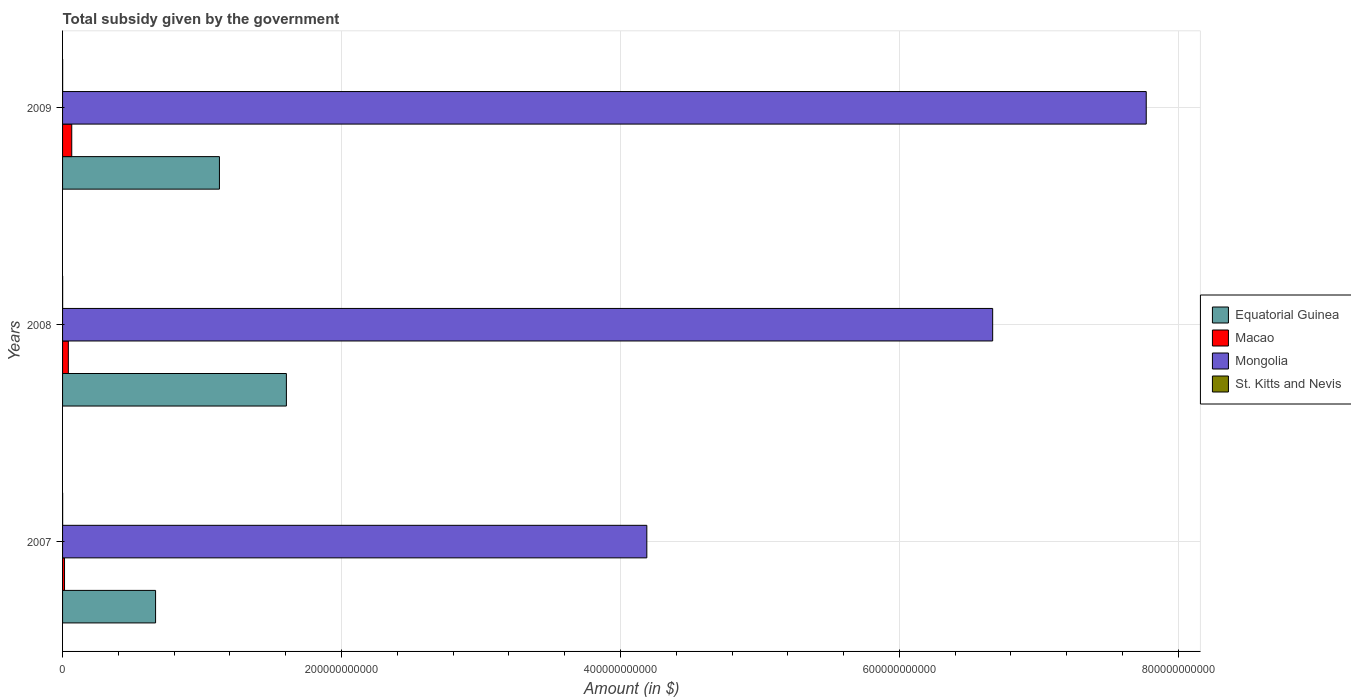How many groups of bars are there?
Offer a very short reply. 3. Are the number of bars per tick equal to the number of legend labels?
Keep it short and to the point. Yes. How many bars are there on the 1st tick from the top?
Ensure brevity in your answer.  4. In how many cases, is the number of bars for a given year not equal to the number of legend labels?
Provide a succinct answer. 0. What is the total revenue collected by the government in Mongolia in 2007?
Keep it short and to the point. 4.19e+11. Across all years, what is the maximum total revenue collected by the government in Equatorial Guinea?
Provide a succinct answer. 1.60e+11. Across all years, what is the minimum total revenue collected by the government in Equatorial Guinea?
Make the answer very short. 6.67e+1. In which year was the total revenue collected by the government in St. Kitts and Nevis maximum?
Your answer should be very brief. 2009. What is the total total revenue collected by the government in Mongolia in the graph?
Ensure brevity in your answer.  1.86e+12. What is the difference between the total revenue collected by the government in Mongolia in 2007 and that in 2008?
Provide a succinct answer. -2.48e+11. What is the difference between the total revenue collected by the government in Macao in 2009 and the total revenue collected by the government in Mongolia in 2008?
Provide a short and direct response. -6.60e+11. What is the average total revenue collected by the government in Mongolia per year?
Make the answer very short. 6.21e+11. In the year 2009, what is the difference between the total revenue collected by the government in Equatorial Guinea and total revenue collected by the government in Mongolia?
Make the answer very short. -6.64e+11. What is the ratio of the total revenue collected by the government in Mongolia in 2007 to that in 2009?
Your answer should be very brief. 0.54. What is the difference between the highest and the second highest total revenue collected by the government in Mongolia?
Your response must be concise. 1.10e+11. What is the difference between the highest and the lowest total revenue collected by the government in Equatorial Guinea?
Give a very brief answer. 9.38e+1. In how many years, is the total revenue collected by the government in St. Kitts and Nevis greater than the average total revenue collected by the government in St. Kitts and Nevis taken over all years?
Give a very brief answer. 2. Is it the case that in every year, the sum of the total revenue collected by the government in St. Kitts and Nevis and total revenue collected by the government in Macao is greater than the sum of total revenue collected by the government in Mongolia and total revenue collected by the government in Equatorial Guinea?
Provide a succinct answer. No. What does the 4th bar from the top in 2008 represents?
Your answer should be compact. Equatorial Guinea. What does the 2nd bar from the bottom in 2008 represents?
Your answer should be compact. Macao. Is it the case that in every year, the sum of the total revenue collected by the government in Macao and total revenue collected by the government in Mongolia is greater than the total revenue collected by the government in Equatorial Guinea?
Ensure brevity in your answer.  Yes. Are all the bars in the graph horizontal?
Your answer should be very brief. Yes. How many years are there in the graph?
Keep it short and to the point. 3. What is the difference between two consecutive major ticks on the X-axis?
Give a very brief answer. 2.00e+11. Are the values on the major ticks of X-axis written in scientific E-notation?
Provide a short and direct response. No. Does the graph contain any zero values?
Provide a succinct answer. No. Does the graph contain grids?
Your response must be concise. Yes. Where does the legend appear in the graph?
Provide a succinct answer. Center right. How many legend labels are there?
Give a very brief answer. 4. What is the title of the graph?
Provide a short and direct response. Total subsidy given by the government. What is the label or title of the X-axis?
Your answer should be very brief. Amount (in $). What is the Amount (in $) in Equatorial Guinea in 2007?
Your answer should be compact. 6.67e+1. What is the Amount (in $) of Macao in 2007?
Provide a short and direct response. 1.41e+09. What is the Amount (in $) of Mongolia in 2007?
Make the answer very short. 4.19e+11. What is the Amount (in $) in St. Kitts and Nevis in 2007?
Your answer should be compact. 5.41e+07. What is the Amount (in $) in Equatorial Guinea in 2008?
Provide a short and direct response. 1.60e+11. What is the Amount (in $) in Macao in 2008?
Provide a succinct answer. 4.14e+09. What is the Amount (in $) of Mongolia in 2008?
Ensure brevity in your answer.  6.67e+11. What is the Amount (in $) in St. Kitts and Nevis in 2008?
Make the answer very short. 5.86e+07. What is the Amount (in $) of Equatorial Guinea in 2009?
Provide a short and direct response. 1.12e+11. What is the Amount (in $) of Macao in 2009?
Your response must be concise. 6.59e+09. What is the Amount (in $) of Mongolia in 2009?
Offer a very short reply. 7.77e+11. What is the Amount (in $) of St. Kitts and Nevis in 2009?
Make the answer very short. 5.91e+07. Across all years, what is the maximum Amount (in $) in Equatorial Guinea?
Keep it short and to the point. 1.60e+11. Across all years, what is the maximum Amount (in $) of Macao?
Your answer should be compact. 6.59e+09. Across all years, what is the maximum Amount (in $) of Mongolia?
Give a very brief answer. 7.77e+11. Across all years, what is the maximum Amount (in $) of St. Kitts and Nevis?
Offer a very short reply. 5.91e+07. Across all years, what is the minimum Amount (in $) in Equatorial Guinea?
Provide a succinct answer. 6.67e+1. Across all years, what is the minimum Amount (in $) in Macao?
Your answer should be very brief. 1.41e+09. Across all years, what is the minimum Amount (in $) of Mongolia?
Make the answer very short. 4.19e+11. Across all years, what is the minimum Amount (in $) in St. Kitts and Nevis?
Keep it short and to the point. 5.41e+07. What is the total Amount (in $) in Equatorial Guinea in the graph?
Your answer should be compact. 3.40e+11. What is the total Amount (in $) of Macao in the graph?
Make the answer very short. 1.21e+1. What is the total Amount (in $) in Mongolia in the graph?
Give a very brief answer. 1.86e+12. What is the total Amount (in $) in St. Kitts and Nevis in the graph?
Give a very brief answer. 1.72e+08. What is the difference between the Amount (in $) in Equatorial Guinea in 2007 and that in 2008?
Your answer should be compact. -9.38e+1. What is the difference between the Amount (in $) of Macao in 2007 and that in 2008?
Offer a terse response. -2.72e+09. What is the difference between the Amount (in $) in Mongolia in 2007 and that in 2008?
Your response must be concise. -2.48e+11. What is the difference between the Amount (in $) in St. Kitts and Nevis in 2007 and that in 2008?
Make the answer very short. -4.50e+06. What is the difference between the Amount (in $) in Equatorial Guinea in 2007 and that in 2009?
Your response must be concise. -4.58e+1. What is the difference between the Amount (in $) of Macao in 2007 and that in 2009?
Your answer should be compact. -5.17e+09. What is the difference between the Amount (in $) in Mongolia in 2007 and that in 2009?
Keep it short and to the point. -3.58e+11. What is the difference between the Amount (in $) in St. Kitts and Nevis in 2007 and that in 2009?
Offer a terse response. -5.00e+06. What is the difference between the Amount (in $) of Equatorial Guinea in 2008 and that in 2009?
Offer a very short reply. 4.80e+1. What is the difference between the Amount (in $) of Macao in 2008 and that in 2009?
Your answer should be very brief. -2.45e+09. What is the difference between the Amount (in $) in Mongolia in 2008 and that in 2009?
Offer a terse response. -1.10e+11. What is the difference between the Amount (in $) of St. Kitts and Nevis in 2008 and that in 2009?
Make the answer very short. -5.00e+05. What is the difference between the Amount (in $) of Equatorial Guinea in 2007 and the Amount (in $) of Macao in 2008?
Keep it short and to the point. 6.26e+1. What is the difference between the Amount (in $) in Equatorial Guinea in 2007 and the Amount (in $) in Mongolia in 2008?
Your answer should be compact. -6.00e+11. What is the difference between the Amount (in $) in Equatorial Guinea in 2007 and the Amount (in $) in St. Kitts and Nevis in 2008?
Ensure brevity in your answer.  6.66e+1. What is the difference between the Amount (in $) in Macao in 2007 and the Amount (in $) in Mongolia in 2008?
Ensure brevity in your answer.  -6.65e+11. What is the difference between the Amount (in $) in Macao in 2007 and the Amount (in $) in St. Kitts and Nevis in 2008?
Your answer should be compact. 1.35e+09. What is the difference between the Amount (in $) in Mongolia in 2007 and the Amount (in $) in St. Kitts and Nevis in 2008?
Your answer should be compact. 4.19e+11. What is the difference between the Amount (in $) of Equatorial Guinea in 2007 and the Amount (in $) of Macao in 2009?
Keep it short and to the point. 6.01e+1. What is the difference between the Amount (in $) in Equatorial Guinea in 2007 and the Amount (in $) in Mongolia in 2009?
Your answer should be compact. -7.10e+11. What is the difference between the Amount (in $) of Equatorial Guinea in 2007 and the Amount (in $) of St. Kitts and Nevis in 2009?
Your response must be concise. 6.66e+1. What is the difference between the Amount (in $) of Macao in 2007 and the Amount (in $) of Mongolia in 2009?
Your answer should be very brief. -7.76e+11. What is the difference between the Amount (in $) of Macao in 2007 and the Amount (in $) of St. Kitts and Nevis in 2009?
Ensure brevity in your answer.  1.35e+09. What is the difference between the Amount (in $) in Mongolia in 2007 and the Amount (in $) in St. Kitts and Nevis in 2009?
Your response must be concise. 4.19e+11. What is the difference between the Amount (in $) of Equatorial Guinea in 2008 and the Amount (in $) of Macao in 2009?
Keep it short and to the point. 1.54e+11. What is the difference between the Amount (in $) of Equatorial Guinea in 2008 and the Amount (in $) of Mongolia in 2009?
Your answer should be very brief. -6.16e+11. What is the difference between the Amount (in $) of Equatorial Guinea in 2008 and the Amount (in $) of St. Kitts and Nevis in 2009?
Give a very brief answer. 1.60e+11. What is the difference between the Amount (in $) in Macao in 2008 and the Amount (in $) in Mongolia in 2009?
Your answer should be very brief. -7.73e+11. What is the difference between the Amount (in $) of Macao in 2008 and the Amount (in $) of St. Kitts and Nevis in 2009?
Your answer should be very brief. 4.08e+09. What is the difference between the Amount (in $) of Mongolia in 2008 and the Amount (in $) of St. Kitts and Nevis in 2009?
Provide a short and direct response. 6.67e+11. What is the average Amount (in $) of Equatorial Guinea per year?
Keep it short and to the point. 1.13e+11. What is the average Amount (in $) in Macao per year?
Make the answer very short. 4.05e+09. What is the average Amount (in $) of Mongolia per year?
Give a very brief answer. 6.21e+11. What is the average Amount (in $) of St. Kitts and Nevis per year?
Your answer should be compact. 5.73e+07. In the year 2007, what is the difference between the Amount (in $) in Equatorial Guinea and Amount (in $) in Macao?
Keep it short and to the point. 6.53e+1. In the year 2007, what is the difference between the Amount (in $) of Equatorial Guinea and Amount (in $) of Mongolia?
Make the answer very short. -3.52e+11. In the year 2007, what is the difference between the Amount (in $) of Equatorial Guinea and Amount (in $) of St. Kitts and Nevis?
Your response must be concise. 6.66e+1. In the year 2007, what is the difference between the Amount (in $) of Macao and Amount (in $) of Mongolia?
Provide a short and direct response. -4.17e+11. In the year 2007, what is the difference between the Amount (in $) in Macao and Amount (in $) in St. Kitts and Nevis?
Your response must be concise. 1.36e+09. In the year 2007, what is the difference between the Amount (in $) of Mongolia and Amount (in $) of St. Kitts and Nevis?
Keep it short and to the point. 4.19e+11. In the year 2008, what is the difference between the Amount (in $) in Equatorial Guinea and Amount (in $) in Macao?
Your answer should be compact. 1.56e+11. In the year 2008, what is the difference between the Amount (in $) in Equatorial Guinea and Amount (in $) in Mongolia?
Make the answer very short. -5.06e+11. In the year 2008, what is the difference between the Amount (in $) of Equatorial Guinea and Amount (in $) of St. Kitts and Nevis?
Offer a very short reply. 1.60e+11. In the year 2008, what is the difference between the Amount (in $) in Macao and Amount (in $) in Mongolia?
Your answer should be very brief. -6.63e+11. In the year 2008, what is the difference between the Amount (in $) in Macao and Amount (in $) in St. Kitts and Nevis?
Keep it short and to the point. 4.08e+09. In the year 2008, what is the difference between the Amount (in $) of Mongolia and Amount (in $) of St. Kitts and Nevis?
Give a very brief answer. 6.67e+11. In the year 2009, what is the difference between the Amount (in $) of Equatorial Guinea and Amount (in $) of Macao?
Your response must be concise. 1.06e+11. In the year 2009, what is the difference between the Amount (in $) of Equatorial Guinea and Amount (in $) of Mongolia?
Keep it short and to the point. -6.64e+11. In the year 2009, what is the difference between the Amount (in $) in Equatorial Guinea and Amount (in $) in St. Kitts and Nevis?
Keep it short and to the point. 1.12e+11. In the year 2009, what is the difference between the Amount (in $) in Macao and Amount (in $) in Mongolia?
Your answer should be compact. -7.70e+11. In the year 2009, what is the difference between the Amount (in $) of Macao and Amount (in $) of St. Kitts and Nevis?
Your answer should be compact. 6.53e+09. In the year 2009, what is the difference between the Amount (in $) in Mongolia and Amount (in $) in St. Kitts and Nevis?
Your answer should be compact. 7.77e+11. What is the ratio of the Amount (in $) in Equatorial Guinea in 2007 to that in 2008?
Your response must be concise. 0.42. What is the ratio of the Amount (in $) of Macao in 2007 to that in 2008?
Give a very brief answer. 0.34. What is the ratio of the Amount (in $) of Mongolia in 2007 to that in 2008?
Ensure brevity in your answer.  0.63. What is the ratio of the Amount (in $) in St. Kitts and Nevis in 2007 to that in 2008?
Make the answer very short. 0.92. What is the ratio of the Amount (in $) in Equatorial Guinea in 2007 to that in 2009?
Give a very brief answer. 0.59. What is the ratio of the Amount (in $) in Macao in 2007 to that in 2009?
Give a very brief answer. 0.21. What is the ratio of the Amount (in $) of Mongolia in 2007 to that in 2009?
Your answer should be compact. 0.54. What is the ratio of the Amount (in $) of St. Kitts and Nevis in 2007 to that in 2009?
Ensure brevity in your answer.  0.92. What is the ratio of the Amount (in $) of Equatorial Guinea in 2008 to that in 2009?
Keep it short and to the point. 1.43. What is the ratio of the Amount (in $) in Macao in 2008 to that in 2009?
Provide a short and direct response. 0.63. What is the ratio of the Amount (in $) in Mongolia in 2008 to that in 2009?
Offer a terse response. 0.86. What is the difference between the highest and the second highest Amount (in $) in Equatorial Guinea?
Your answer should be very brief. 4.80e+1. What is the difference between the highest and the second highest Amount (in $) of Macao?
Ensure brevity in your answer.  2.45e+09. What is the difference between the highest and the second highest Amount (in $) of Mongolia?
Give a very brief answer. 1.10e+11. What is the difference between the highest and the lowest Amount (in $) of Equatorial Guinea?
Keep it short and to the point. 9.38e+1. What is the difference between the highest and the lowest Amount (in $) in Macao?
Give a very brief answer. 5.17e+09. What is the difference between the highest and the lowest Amount (in $) of Mongolia?
Your response must be concise. 3.58e+11. 